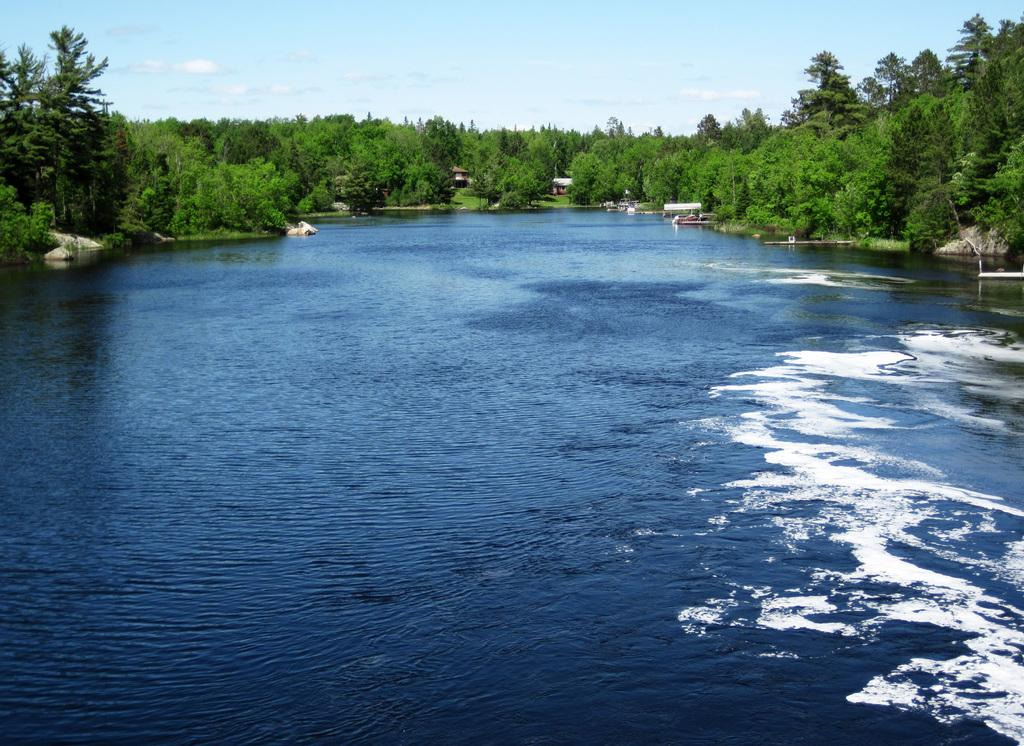What is the main feature of the image? There is a large water body in the image. What else can be seen near the water body? There are rocks visible in the image. What type of vegetation is present in the image? There is grass in the image. Are there any structures visible in the image? Yes, there are houses on the ground in the image. What else can be seen in the image besides the water body and houses? There is a group of trees in the image. How would you describe the sky in the image? The sky is visible in the image and appears cloudy. What is the manager's role in the aftermath of the harbor incident in the image? There is no mention of a manager, harbor, or incident in the image. The image features a large water body, rocks, grass, houses, trees, and a cloudy sky. 